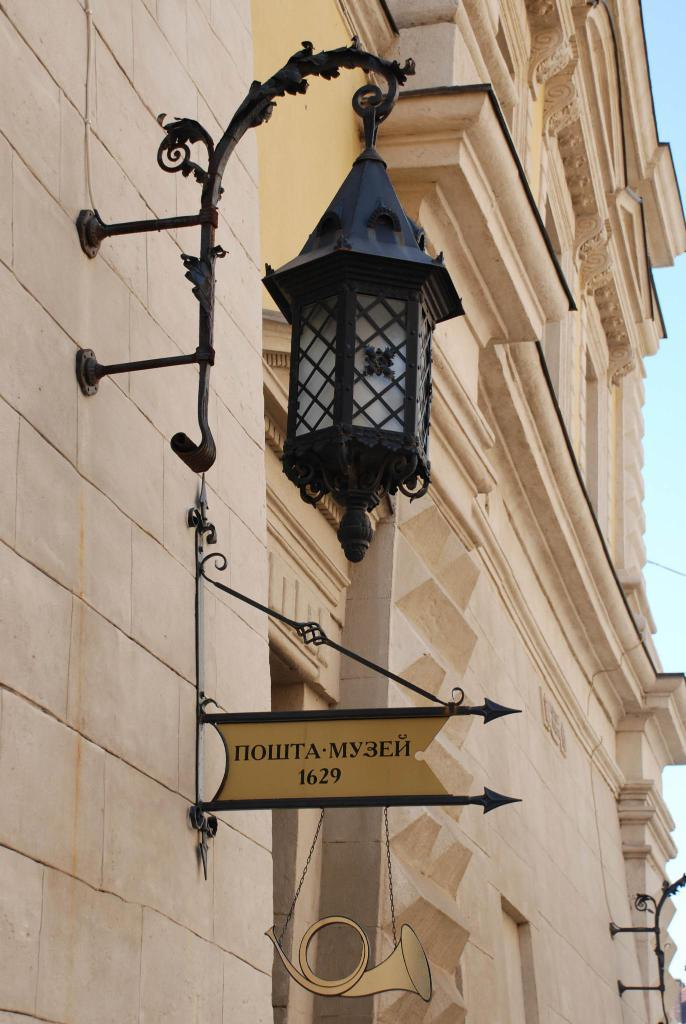What is the main object in the image? There is a board in the image. Can you describe the light in the image? A light is attached to the wall of a building. What can be seen in the background of the image? The background of the image includes the sky. How does the seed grow on the board in the image? There is no seed present in the image, so it cannot grow on the board. 